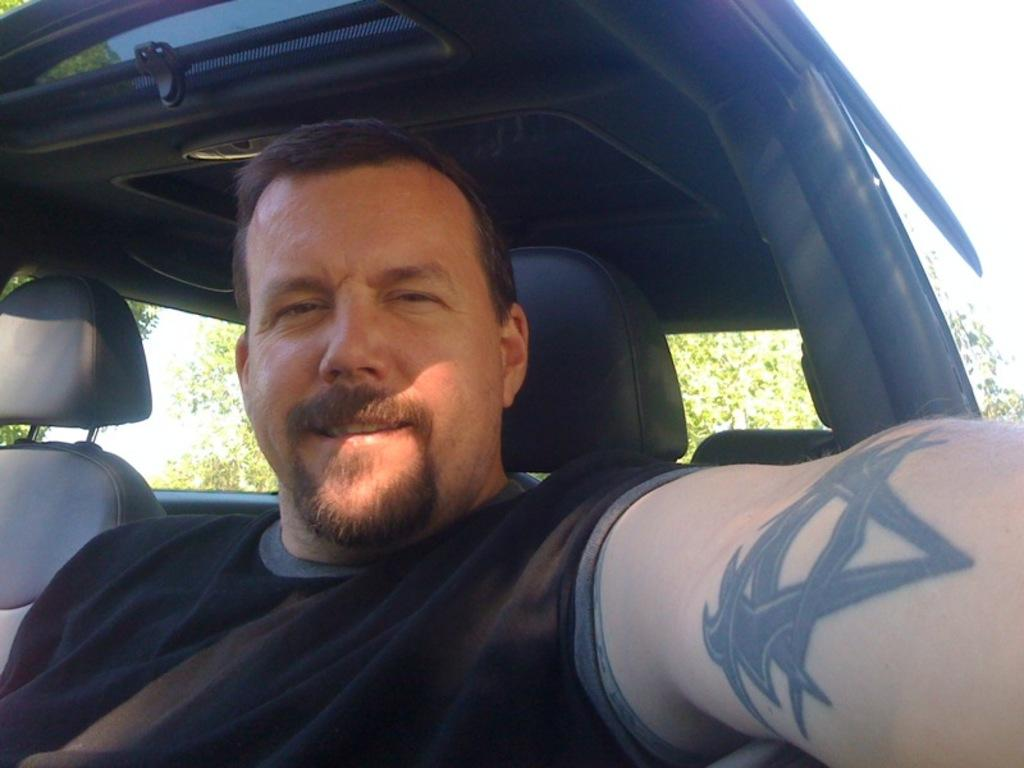What is the man in the image doing? The man is sitting in a car in the image. What can be seen in the background of the image? There are trees visible in the background of the image. What type of light can be seen reflecting off the car's windshield in the image? There is no specific light source mentioned in the image, and therefore no reflection can be observed. 